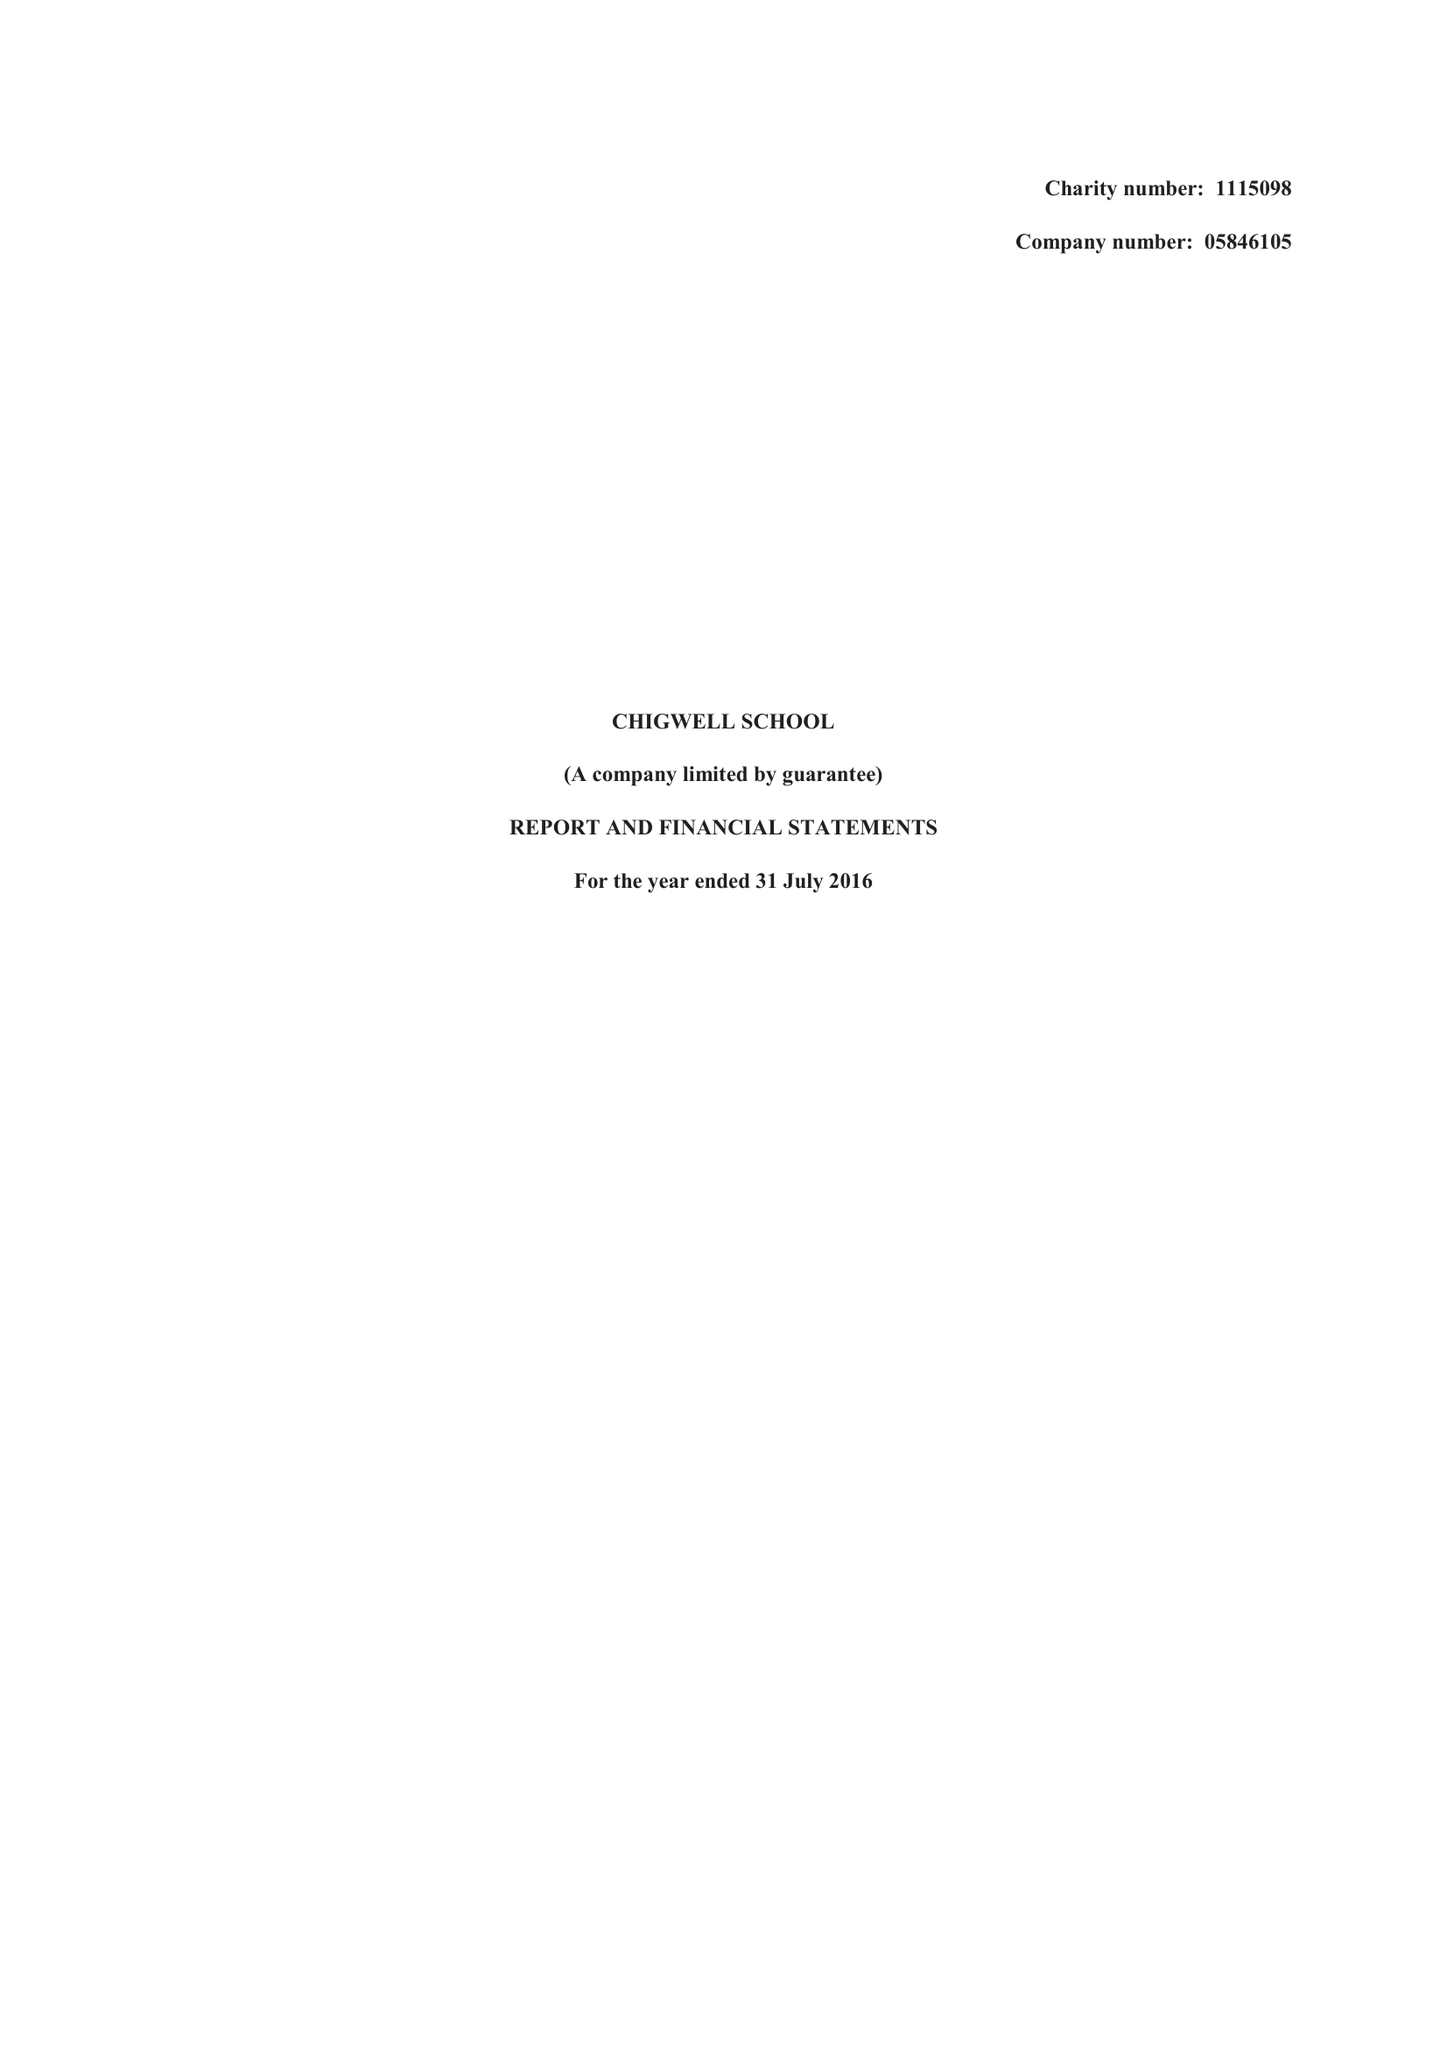What is the value for the charity_name?
Answer the question using a single word or phrase. Chigwell School 